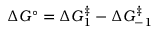Convert formula to latex. <formula><loc_0><loc_0><loc_500><loc_500>\Delta G ^ { \circ } = \Delta G _ { 1 } ^ { \ddagger } - \Delta G _ { - 1 } ^ { \ddagger }</formula> 